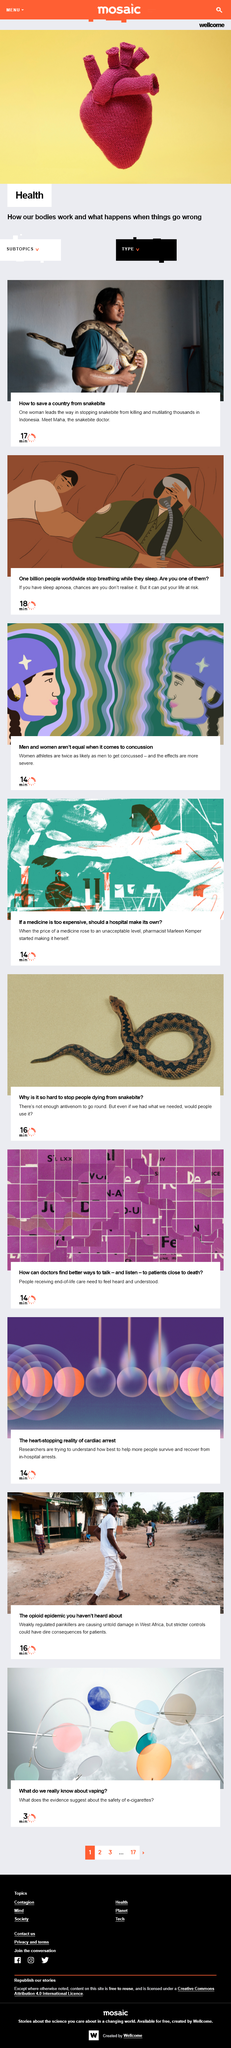Indicate a few pertinent items in this graphic. Women athletes are twice as likely as men to get concussed, and the effects are more severe, which means that men and women are not regarded as equal when it comes to concussion. The individual known as 'snakebite doctor' is referred to as Maha. The first video is approximately 14 minutes in length. Using e-cigarettes is also known as vaping. In West Africa, opioid painkillers are not well regulated, but rather, they are poorly controlled, and this poses a significant risk to public health. 